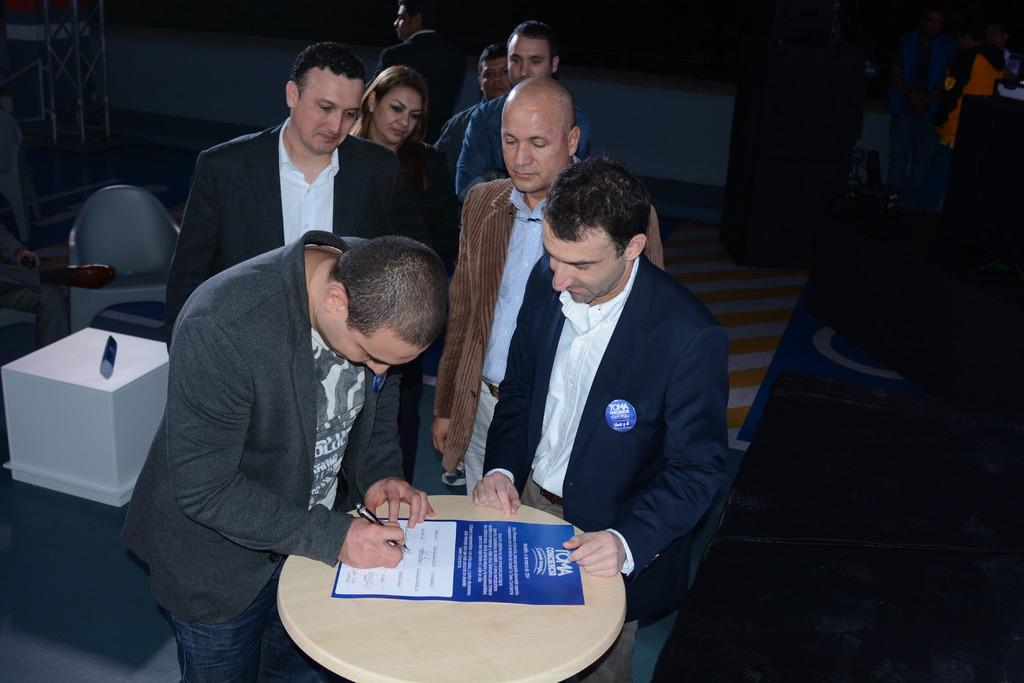How many people are present in the image? There are many people standing in the image. What object can be seen in the image besides the people? There is a table in the image. What is on the table? A sheet of paper is on the table. What is the man holding in his hand? The man is holding a pen in his hand. What type of friction is being caused by the people in the image? There is no information about friction in the image; it only shows people standing, a table, a sheet of paper, and a man holding a pen. 